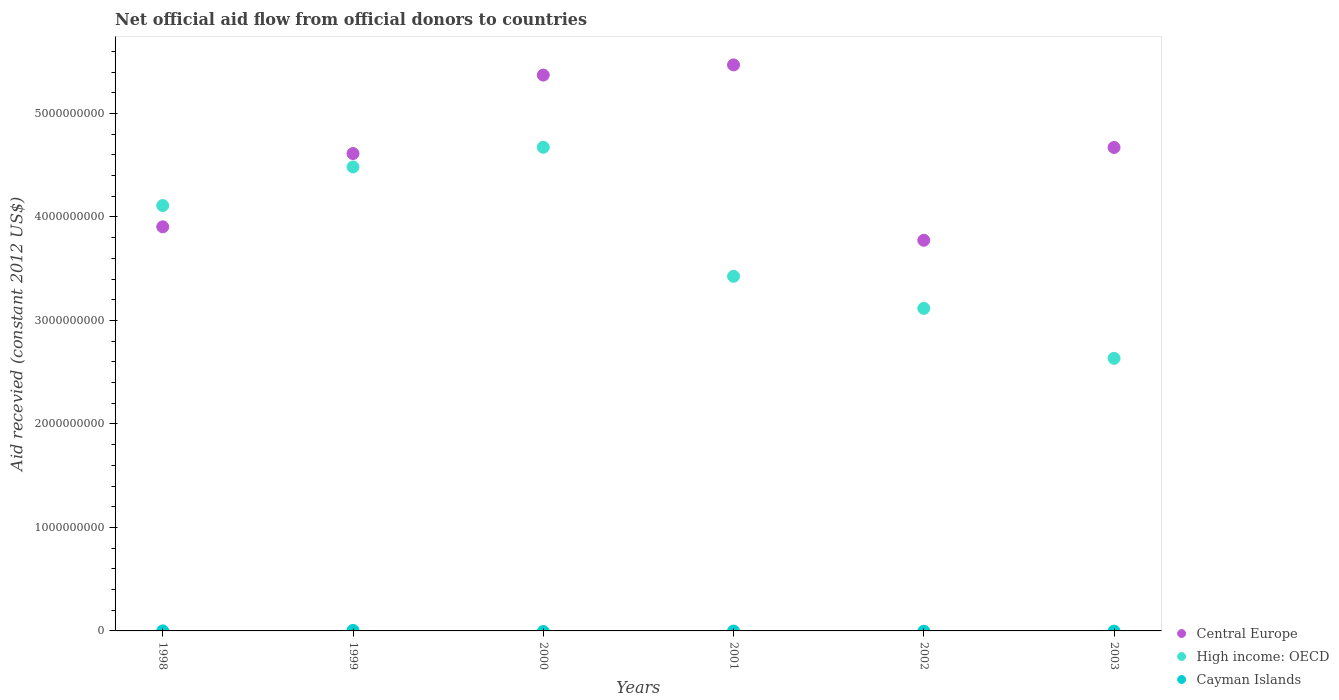How many different coloured dotlines are there?
Offer a very short reply. 3. What is the total aid received in High income: OECD in 2003?
Your response must be concise. 2.63e+09. Across all years, what is the maximum total aid received in High income: OECD?
Your response must be concise. 4.67e+09. Across all years, what is the minimum total aid received in High income: OECD?
Make the answer very short. 2.63e+09. What is the total total aid received in Central Europe in the graph?
Keep it short and to the point. 2.78e+1. What is the difference between the total aid received in Central Europe in 1999 and that in 2001?
Give a very brief answer. -8.56e+08. What is the difference between the total aid received in High income: OECD in 2002 and the total aid received in Central Europe in 1999?
Ensure brevity in your answer.  -1.50e+09. What is the average total aid received in Central Europe per year?
Your answer should be very brief. 4.63e+09. In the year 2001, what is the difference between the total aid received in Central Europe and total aid received in High income: OECD?
Offer a terse response. 2.04e+09. What is the ratio of the total aid received in High income: OECD in 2000 to that in 2003?
Provide a short and direct response. 1.77. Is the total aid received in Central Europe in 2000 less than that in 2001?
Offer a very short reply. Yes. What is the difference between the highest and the second highest total aid received in High income: OECD?
Give a very brief answer. 1.90e+08. What is the difference between the highest and the lowest total aid received in Cayman Islands?
Offer a very short reply. 4.62e+06. Is the sum of the total aid received in High income: OECD in 1998 and 2002 greater than the maximum total aid received in Cayman Islands across all years?
Offer a very short reply. Yes. How many years are there in the graph?
Keep it short and to the point. 6. What is the difference between two consecutive major ticks on the Y-axis?
Provide a short and direct response. 1.00e+09. Are the values on the major ticks of Y-axis written in scientific E-notation?
Ensure brevity in your answer.  No. Does the graph contain any zero values?
Your response must be concise. Yes. Where does the legend appear in the graph?
Offer a terse response. Bottom right. What is the title of the graph?
Make the answer very short. Net official aid flow from official donors to countries. What is the label or title of the X-axis?
Provide a short and direct response. Years. What is the label or title of the Y-axis?
Your answer should be very brief. Aid recevied (constant 2012 US$). What is the Aid recevied (constant 2012 US$) in Central Europe in 1998?
Ensure brevity in your answer.  3.90e+09. What is the Aid recevied (constant 2012 US$) in High income: OECD in 1998?
Give a very brief answer. 4.11e+09. What is the Aid recevied (constant 2012 US$) of Cayman Islands in 1998?
Ensure brevity in your answer.  4.50e+05. What is the Aid recevied (constant 2012 US$) in Central Europe in 1999?
Provide a short and direct response. 4.61e+09. What is the Aid recevied (constant 2012 US$) of High income: OECD in 1999?
Ensure brevity in your answer.  4.48e+09. What is the Aid recevied (constant 2012 US$) of Cayman Islands in 1999?
Your response must be concise. 4.62e+06. What is the Aid recevied (constant 2012 US$) of Central Europe in 2000?
Provide a succinct answer. 5.37e+09. What is the Aid recevied (constant 2012 US$) in High income: OECD in 2000?
Provide a succinct answer. 4.67e+09. What is the Aid recevied (constant 2012 US$) in Central Europe in 2001?
Ensure brevity in your answer.  5.47e+09. What is the Aid recevied (constant 2012 US$) in High income: OECD in 2001?
Provide a short and direct response. 3.43e+09. What is the Aid recevied (constant 2012 US$) of Cayman Islands in 2001?
Ensure brevity in your answer.  0. What is the Aid recevied (constant 2012 US$) in Central Europe in 2002?
Your answer should be very brief. 3.77e+09. What is the Aid recevied (constant 2012 US$) in High income: OECD in 2002?
Offer a very short reply. 3.12e+09. What is the Aid recevied (constant 2012 US$) in Central Europe in 2003?
Your answer should be compact. 4.67e+09. What is the Aid recevied (constant 2012 US$) in High income: OECD in 2003?
Make the answer very short. 2.63e+09. What is the Aid recevied (constant 2012 US$) of Cayman Islands in 2003?
Your answer should be very brief. 0. Across all years, what is the maximum Aid recevied (constant 2012 US$) of Central Europe?
Your answer should be very brief. 5.47e+09. Across all years, what is the maximum Aid recevied (constant 2012 US$) in High income: OECD?
Provide a succinct answer. 4.67e+09. Across all years, what is the maximum Aid recevied (constant 2012 US$) of Cayman Islands?
Keep it short and to the point. 4.62e+06. Across all years, what is the minimum Aid recevied (constant 2012 US$) in Central Europe?
Give a very brief answer. 3.77e+09. Across all years, what is the minimum Aid recevied (constant 2012 US$) in High income: OECD?
Ensure brevity in your answer.  2.63e+09. What is the total Aid recevied (constant 2012 US$) in Central Europe in the graph?
Give a very brief answer. 2.78e+1. What is the total Aid recevied (constant 2012 US$) of High income: OECD in the graph?
Offer a very short reply. 2.24e+1. What is the total Aid recevied (constant 2012 US$) in Cayman Islands in the graph?
Your answer should be very brief. 5.07e+06. What is the difference between the Aid recevied (constant 2012 US$) in Central Europe in 1998 and that in 1999?
Provide a short and direct response. -7.08e+08. What is the difference between the Aid recevied (constant 2012 US$) in High income: OECD in 1998 and that in 1999?
Offer a very short reply. -3.73e+08. What is the difference between the Aid recevied (constant 2012 US$) in Cayman Islands in 1998 and that in 1999?
Provide a short and direct response. -4.17e+06. What is the difference between the Aid recevied (constant 2012 US$) in Central Europe in 1998 and that in 2000?
Your response must be concise. -1.47e+09. What is the difference between the Aid recevied (constant 2012 US$) in High income: OECD in 1998 and that in 2000?
Provide a short and direct response. -5.63e+08. What is the difference between the Aid recevied (constant 2012 US$) of Central Europe in 1998 and that in 2001?
Provide a short and direct response. -1.56e+09. What is the difference between the Aid recevied (constant 2012 US$) of High income: OECD in 1998 and that in 2001?
Make the answer very short. 6.84e+08. What is the difference between the Aid recevied (constant 2012 US$) in Central Europe in 1998 and that in 2002?
Your answer should be compact. 1.30e+08. What is the difference between the Aid recevied (constant 2012 US$) in High income: OECD in 1998 and that in 2002?
Your response must be concise. 9.93e+08. What is the difference between the Aid recevied (constant 2012 US$) of Central Europe in 1998 and that in 2003?
Make the answer very short. -7.67e+08. What is the difference between the Aid recevied (constant 2012 US$) in High income: OECD in 1998 and that in 2003?
Offer a very short reply. 1.48e+09. What is the difference between the Aid recevied (constant 2012 US$) in Central Europe in 1999 and that in 2000?
Offer a very short reply. -7.58e+08. What is the difference between the Aid recevied (constant 2012 US$) of High income: OECD in 1999 and that in 2000?
Your response must be concise. -1.90e+08. What is the difference between the Aid recevied (constant 2012 US$) of Central Europe in 1999 and that in 2001?
Give a very brief answer. -8.56e+08. What is the difference between the Aid recevied (constant 2012 US$) of High income: OECD in 1999 and that in 2001?
Offer a very short reply. 1.06e+09. What is the difference between the Aid recevied (constant 2012 US$) of Central Europe in 1999 and that in 2002?
Give a very brief answer. 8.38e+08. What is the difference between the Aid recevied (constant 2012 US$) of High income: OECD in 1999 and that in 2002?
Your answer should be compact. 1.37e+09. What is the difference between the Aid recevied (constant 2012 US$) in Central Europe in 1999 and that in 2003?
Provide a short and direct response. -5.87e+07. What is the difference between the Aid recevied (constant 2012 US$) of High income: OECD in 1999 and that in 2003?
Your answer should be very brief. 1.85e+09. What is the difference between the Aid recevied (constant 2012 US$) in Central Europe in 2000 and that in 2001?
Give a very brief answer. -9.83e+07. What is the difference between the Aid recevied (constant 2012 US$) in High income: OECD in 2000 and that in 2001?
Make the answer very short. 1.25e+09. What is the difference between the Aid recevied (constant 2012 US$) of Central Europe in 2000 and that in 2002?
Give a very brief answer. 1.60e+09. What is the difference between the Aid recevied (constant 2012 US$) in High income: OECD in 2000 and that in 2002?
Make the answer very short. 1.56e+09. What is the difference between the Aid recevied (constant 2012 US$) in Central Europe in 2000 and that in 2003?
Make the answer very short. 6.99e+08. What is the difference between the Aid recevied (constant 2012 US$) in High income: OECD in 2000 and that in 2003?
Offer a very short reply. 2.04e+09. What is the difference between the Aid recevied (constant 2012 US$) of Central Europe in 2001 and that in 2002?
Keep it short and to the point. 1.69e+09. What is the difference between the Aid recevied (constant 2012 US$) of High income: OECD in 2001 and that in 2002?
Your response must be concise. 3.10e+08. What is the difference between the Aid recevied (constant 2012 US$) in Central Europe in 2001 and that in 2003?
Offer a terse response. 7.98e+08. What is the difference between the Aid recevied (constant 2012 US$) in High income: OECD in 2001 and that in 2003?
Ensure brevity in your answer.  7.93e+08. What is the difference between the Aid recevied (constant 2012 US$) in Central Europe in 2002 and that in 2003?
Offer a terse response. -8.97e+08. What is the difference between the Aid recevied (constant 2012 US$) in High income: OECD in 2002 and that in 2003?
Ensure brevity in your answer.  4.83e+08. What is the difference between the Aid recevied (constant 2012 US$) of Central Europe in 1998 and the Aid recevied (constant 2012 US$) of High income: OECD in 1999?
Offer a terse response. -5.78e+08. What is the difference between the Aid recevied (constant 2012 US$) of Central Europe in 1998 and the Aid recevied (constant 2012 US$) of Cayman Islands in 1999?
Give a very brief answer. 3.90e+09. What is the difference between the Aid recevied (constant 2012 US$) in High income: OECD in 1998 and the Aid recevied (constant 2012 US$) in Cayman Islands in 1999?
Provide a succinct answer. 4.11e+09. What is the difference between the Aid recevied (constant 2012 US$) in Central Europe in 1998 and the Aid recevied (constant 2012 US$) in High income: OECD in 2000?
Offer a terse response. -7.68e+08. What is the difference between the Aid recevied (constant 2012 US$) in Central Europe in 1998 and the Aid recevied (constant 2012 US$) in High income: OECD in 2001?
Your answer should be compact. 4.78e+08. What is the difference between the Aid recevied (constant 2012 US$) in Central Europe in 1998 and the Aid recevied (constant 2012 US$) in High income: OECD in 2002?
Provide a short and direct response. 7.88e+08. What is the difference between the Aid recevied (constant 2012 US$) in Central Europe in 1998 and the Aid recevied (constant 2012 US$) in High income: OECD in 2003?
Provide a short and direct response. 1.27e+09. What is the difference between the Aid recevied (constant 2012 US$) in Central Europe in 1999 and the Aid recevied (constant 2012 US$) in High income: OECD in 2000?
Your response must be concise. -6.05e+07. What is the difference between the Aid recevied (constant 2012 US$) in Central Europe in 1999 and the Aid recevied (constant 2012 US$) in High income: OECD in 2001?
Ensure brevity in your answer.  1.19e+09. What is the difference between the Aid recevied (constant 2012 US$) in Central Europe in 1999 and the Aid recevied (constant 2012 US$) in High income: OECD in 2002?
Provide a short and direct response. 1.50e+09. What is the difference between the Aid recevied (constant 2012 US$) of Central Europe in 1999 and the Aid recevied (constant 2012 US$) of High income: OECD in 2003?
Offer a very short reply. 1.98e+09. What is the difference between the Aid recevied (constant 2012 US$) of Central Europe in 2000 and the Aid recevied (constant 2012 US$) of High income: OECD in 2001?
Provide a short and direct response. 1.94e+09. What is the difference between the Aid recevied (constant 2012 US$) in Central Europe in 2000 and the Aid recevied (constant 2012 US$) in High income: OECD in 2002?
Provide a succinct answer. 2.25e+09. What is the difference between the Aid recevied (constant 2012 US$) of Central Europe in 2000 and the Aid recevied (constant 2012 US$) of High income: OECD in 2003?
Keep it short and to the point. 2.74e+09. What is the difference between the Aid recevied (constant 2012 US$) in Central Europe in 2001 and the Aid recevied (constant 2012 US$) in High income: OECD in 2002?
Your answer should be compact. 2.35e+09. What is the difference between the Aid recevied (constant 2012 US$) in Central Europe in 2001 and the Aid recevied (constant 2012 US$) in High income: OECD in 2003?
Make the answer very short. 2.84e+09. What is the difference between the Aid recevied (constant 2012 US$) in Central Europe in 2002 and the Aid recevied (constant 2012 US$) in High income: OECD in 2003?
Keep it short and to the point. 1.14e+09. What is the average Aid recevied (constant 2012 US$) in Central Europe per year?
Your response must be concise. 4.63e+09. What is the average Aid recevied (constant 2012 US$) in High income: OECD per year?
Make the answer very short. 3.74e+09. What is the average Aid recevied (constant 2012 US$) of Cayman Islands per year?
Offer a terse response. 8.45e+05. In the year 1998, what is the difference between the Aid recevied (constant 2012 US$) of Central Europe and Aid recevied (constant 2012 US$) of High income: OECD?
Offer a terse response. -2.05e+08. In the year 1998, what is the difference between the Aid recevied (constant 2012 US$) of Central Europe and Aid recevied (constant 2012 US$) of Cayman Islands?
Keep it short and to the point. 3.90e+09. In the year 1998, what is the difference between the Aid recevied (constant 2012 US$) in High income: OECD and Aid recevied (constant 2012 US$) in Cayman Islands?
Make the answer very short. 4.11e+09. In the year 1999, what is the difference between the Aid recevied (constant 2012 US$) in Central Europe and Aid recevied (constant 2012 US$) in High income: OECD?
Your answer should be compact. 1.30e+08. In the year 1999, what is the difference between the Aid recevied (constant 2012 US$) of Central Europe and Aid recevied (constant 2012 US$) of Cayman Islands?
Provide a short and direct response. 4.61e+09. In the year 1999, what is the difference between the Aid recevied (constant 2012 US$) of High income: OECD and Aid recevied (constant 2012 US$) of Cayman Islands?
Offer a very short reply. 4.48e+09. In the year 2000, what is the difference between the Aid recevied (constant 2012 US$) of Central Europe and Aid recevied (constant 2012 US$) of High income: OECD?
Make the answer very short. 6.97e+08. In the year 2001, what is the difference between the Aid recevied (constant 2012 US$) of Central Europe and Aid recevied (constant 2012 US$) of High income: OECD?
Provide a short and direct response. 2.04e+09. In the year 2002, what is the difference between the Aid recevied (constant 2012 US$) of Central Europe and Aid recevied (constant 2012 US$) of High income: OECD?
Give a very brief answer. 6.58e+08. In the year 2003, what is the difference between the Aid recevied (constant 2012 US$) in Central Europe and Aid recevied (constant 2012 US$) in High income: OECD?
Ensure brevity in your answer.  2.04e+09. What is the ratio of the Aid recevied (constant 2012 US$) in Central Europe in 1998 to that in 1999?
Offer a terse response. 0.85. What is the ratio of the Aid recevied (constant 2012 US$) in High income: OECD in 1998 to that in 1999?
Your answer should be compact. 0.92. What is the ratio of the Aid recevied (constant 2012 US$) of Cayman Islands in 1998 to that in 1999?
Provide a short and direct response. 0.1. What is the ratio of the Aid recevied (constant 2012 US$) in Central Europe in 1998 to that in 2000?
Your answer should be compact. 0.73. What is the ratio of the Aid recevied (constant 2012 US$) in High income: OECD in 1998 to that in 2000?
Ensure brevity in your answer.  0.88. What is the ratio of the Aid recevied (constant 2012 US$) in Central Europe in 1998 to that in 2001?
Your response must be concise. 0.71. What is the ratio of the Aid recevied (constant 2012 US$) of High income: OECD in 1998 to that in 2001?
Provide a succinct answer. 1.2. What is the ratio of the Aid recevied (constant 2012 US$) of Central Europe in 1998 to that in 2002?
Provide a short and direct response. 1.03. What is the ratio of the Aid recevied (constant 2012 US$) in High income: OECD in 1998 to that in 2002?
Give a very brief answer. 1.32. What is the ratio of the Aid recevied (constant 2012 US$) in Central Europe in 1998 to that in 2003?
Ensure brevity in your answer.  0.84. What is the ratio of the Aid recevied (constant 2012 US$) in High income: OECD in 1998 to that in 2003?
Ensure brevity in your answer.  1.56. What is the ratio of the Aid recevied (constant 2012 US$) of Central Europe in 1999 to that in 2000?
Your response must be concise. 0.86. What is the ratio of the Aid recevied (constant 2012 US$) of High income: OECD in 1999 to that in 2000?
Give a very brief answer. 0.96. What is the ratio of the Aid recevied (constant 2012 US$) of Central Europe in 1999 to that in 2001?
Offer a very short reply. 0.84. What is the ratio of the Aid recevied (constant 2012 US$) of High income: OECD in 1999 to that in 2001?
Provide a short and direct response. 1.31. What is the ratio of the Aid recevied (constant 2012 US$) of Central Europe in 1999 to that in 2002?
Ensure brevity in your answer.  1.22. What is the ratio of the Aid recevied (constant 2012 US$) of High income: OECD in 1999 to that in 2002?
Make the answer very short. 1.44. What is the ratio of the Aid recevied (constant 2012 US$) in Central Europe in 1999 to that in 2003?
Give a very brief answer. 0.99. What is the ratio of the Aid recevied (constant 2012 US$) of High income: OECD in 1999 to that in 2003?
Keep it short and to the point. 1.7. What is the ratio of the Aid recevied (constant 2012 US$) of High income: OECD in 2000 to that in 2001?
Ensure brevity in your answer.  1.36. What is the ratio of the Aid recevied (constant 2012 US$) of Central Europe in 2000 to that in 2002?
Keep it short and to the point. 1.42. What is the ratio of the Aid recevied (constant 2012 US$) of High income: OECD in 2000 to that in 2002?
Give a very brief answer. 1.5. What is the ratio of the Aid recevied (constant 2012 US$) of Central Europe in 2000 to that in 2003?
Offer a very short reply. 1.15. What is the ratio of the Aid recevied (constant 2012 US$) of High income: OECD in 2000 to that in 2003?
Offer a very short reply. 1.77. What is the ratio of the Aid recevied (constant 2012 US$) in Central Europe in 2001 to that in 2002?
Your response must be concise. 1.45. What is the ratio of the Aid recevied (constant 2012 US$) of High income: OECD in 2001 to that in 2002?
Provide a short and direct response. 1.1. What is the ratio of the Aid recevied (constant 2012 US$) in Central Europe in 2001 to that in 2003?
Provide a succinct answer. 1.17. What is the ratio of the Aid recevied (constant 2012 US$) in High income: OECD in 2001 to that in 2003?
Your response must be concise. 1.3. What is the ratio of the Aid recevied (constant 2012 US$) of Central Europe in 2002 to that in 2003?
Provide a short and direct response. 0.81. What is the ratio of the Aid recevied (constant 2012 US$) of High income: OECD in 2002 to that in 2003?
Provide a short and direct response. 1.18. What is the difference between the highest and the second highest Aid recevied (constant 2012 US$) of Central Europe?
Give a very brief answer. 9.83e+07. What is the difference between the highest and the second highest Aid recevied (constant 2012 US$) of High income: OECD?
Your answer should be very brief. 1.90e+08. What is the difference between the highest and the lowest Aid recevied (constant 2012 US$) of Central Europe?
Your response must be concise. 1.69e+09. What is the difference between the highest and the lowest Aid recevied (constant 2012 US$) in High income: OECD?
Provide a short and direct response. 2.04e+09. What is the difference between the highest and the lowest Aid recevied (constant 2012 US$) in Cayman Islands?
Ensure brevity in your answer.  4.62e+06. 